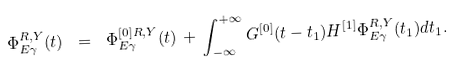Convert formula to latex. <formula><loc_0><loc_0><loc_500><loc_500>\Phi ^ { R , Y } _ { E \gamma } ( t ) \ = \ \Phi ^ { [ 0 ] R , Y } _ { E \gamma } ( t ) \, + \, \int _ { - \infty } ^ { + \infty } G ^ { [ 0 ] } ( t - t _ { 1 } ) H ^ { [ 1 ] } \Phi ^ { R , Y } _ { E \gamma } ( t _ { 1 } ) d t _ { 1 } .</formula> 